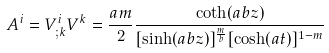Convert formula to latex. <formula><loc_0><loc_0><loc_500><loc_500>A ^ { i } = V ^ { i } _ { ; k } V ^ { k } = \frac { a m } { 2 } \frac { \coth ( a b z ) } { [ \sinh ( a b z ) ] ^ { \frac { m } { b } } [ \cosh ( a t ) ] ^ { 1 - m } }</formula> 